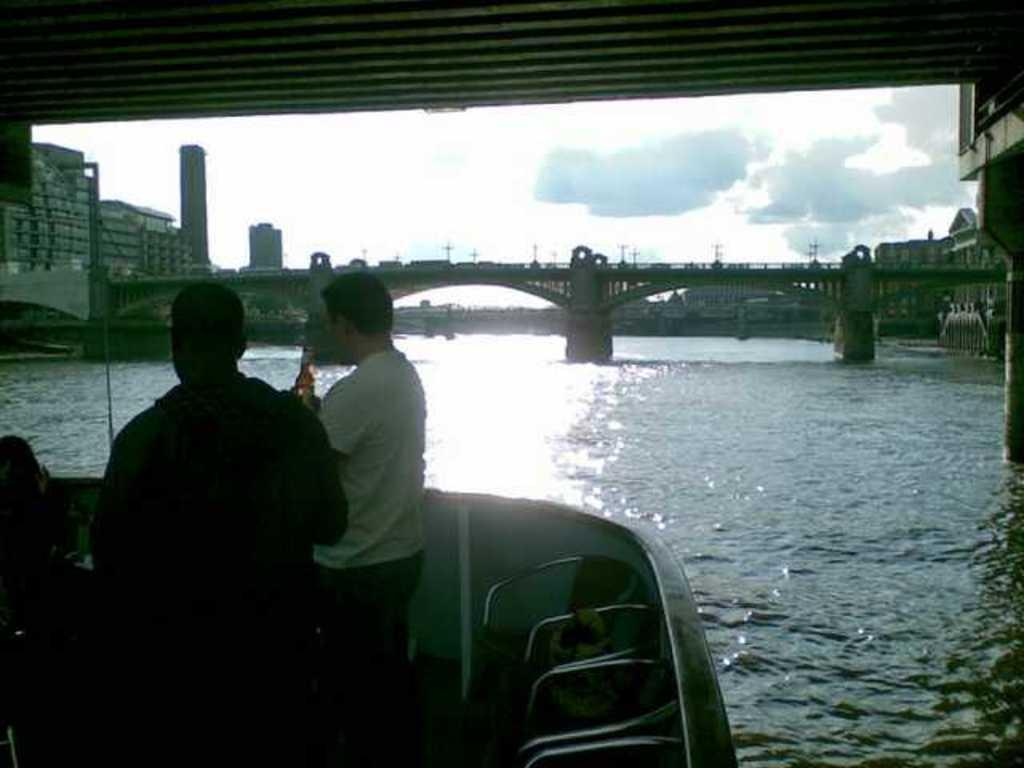How many people are on the boat in the image? There are two people on the boat in the image. Where is the boat located? The boat is on the water. What is visible behind the boat? There is a bridge behind the boat. What can be seen in the distance in the image? There are buildings visible in the background, and the sky is also visible. How does the boat stop while the people are swimming in the image? The image does not show the people swimming, nor does it show the boat stopping. The boat is on the water, but there is no indication of any movement or activity related to swimming or stopping. 